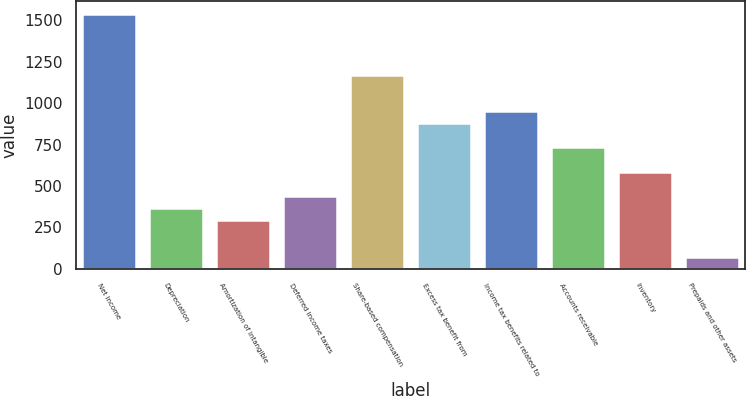<chart> <loc_0><loc_0><loc_500><loc_500><bar_chart><fcel>Net income<fcel>Depreciation<fcel>Amortization of intangible<fcel>Deferred income taxes<fcel>Share-based compensation<fcel>Excess tax benefit from<fcel>Income tax benefits related to<fcel>Accounts receivable<fcel>Inventory<fcel>Prepaids and other assets<nl><fcel>1538.56<fcel>366.4<fcel>293.14<fcel>439.66<fcel>1172.26<fcel>879.22<fcel>952.48<fcel>732.7<fcel>586.18<fcel>73.36<nl></chart> 